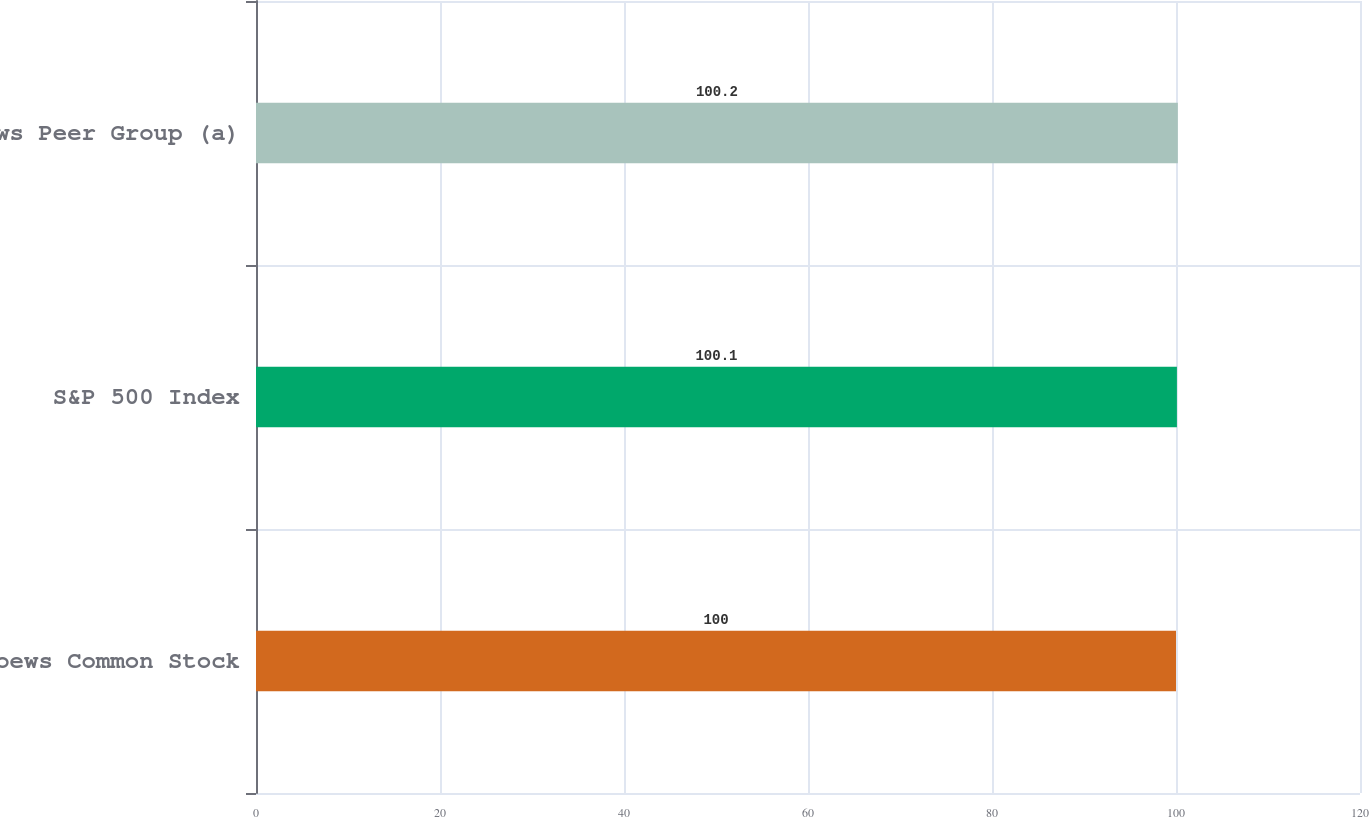Convert chart. <chart><loc_0><loc_0><loc_500><loc_500><bar_chart><fcel>Loews Common Stock<fcel>S&P 500 Index<fcel>Loews Peer Group (a)<nl><fcel>100<fcel>100.1<fcel>100.2<nl></chart> 